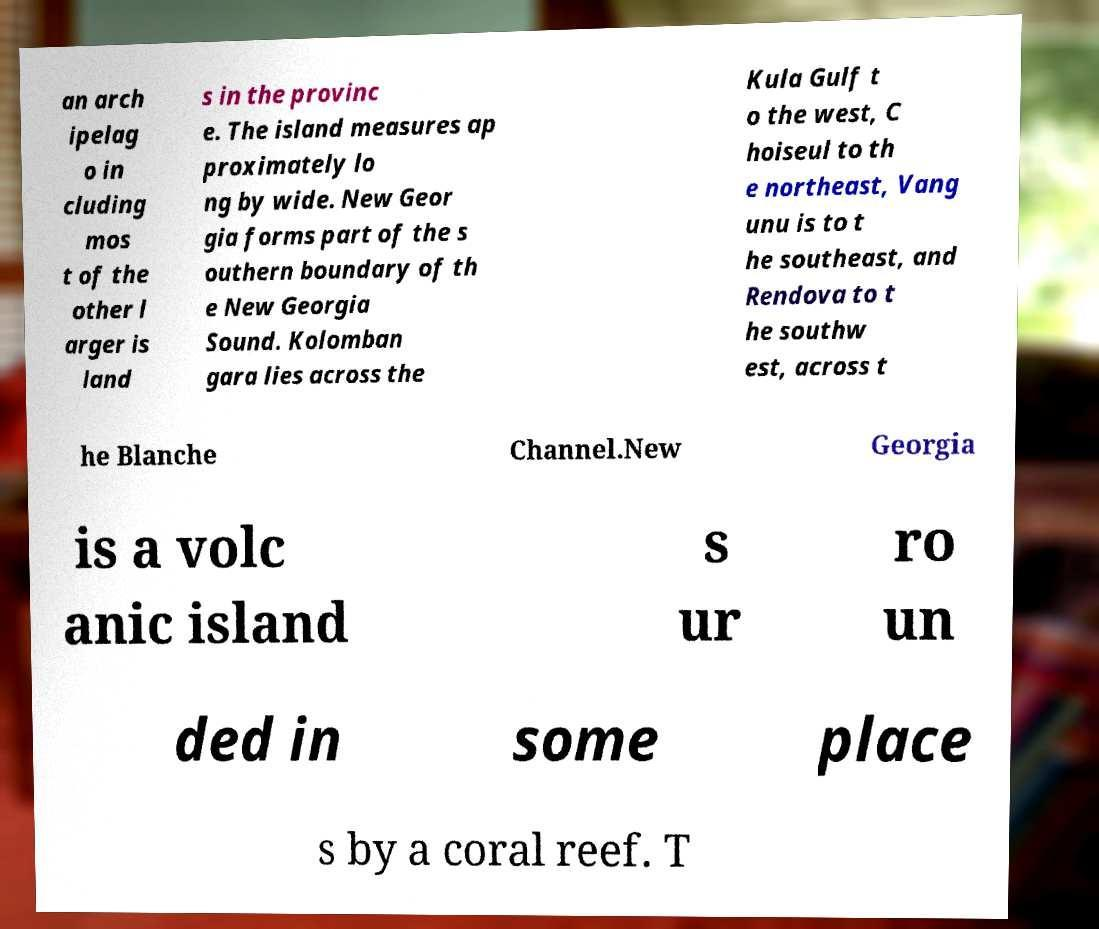Please identify and transcribe the text found in this image. an arch ipelag o in cluding mos t of the other l arger is land s in the provinc e. The island measures ap proximately lo ng by wide. New Geor gia forms part of the s outhern boundary of th e New Georgia Sound. Kolomban gara lies across the Kula Gulf t o the west, C hoiseul to th e northeast, Vang unu is to t he southeast, and Rendova to t he southw est, across t he Blanche Channel.New Georgia is a volc anic island s ur ro un ded in some place s by a coral reef. T 